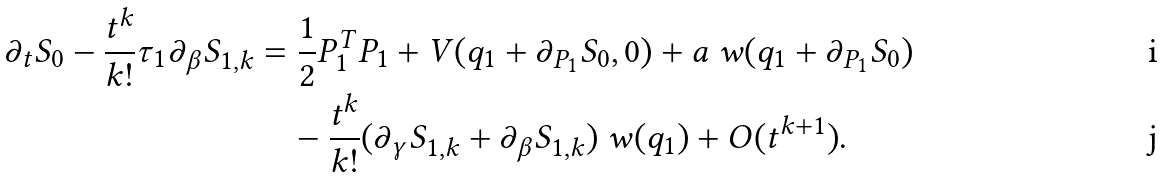Convert formula to latex. <formula><loc_0><loc_0><loc_500><loc_500>\partial _ { t } S _ { 0 } - \frac { t ^ { k } } { k ! } \tau _ { 1 } \partial _ { \beta } S _ { 1 , k } & = \frac { 1 } { 2 } P _ { 1 } ^ { T } P _ { 1 } + V ( q _ { 1 } + \partial _ { P _ { 1 } } S _ { 0 } , 0 ) + a \ w ( q _ { 1 } + \partial _ { P _ { 1 } } S _ { 0 } ) \\ & \quad - \frac { t ^ { k } } { k ! } ( \partial _ { \gamma } S _ { 1 , k } + \partial _ { \beta } S _ { 1 , k } ) \ w ( q _ { 1 } ) + O ( t ^ { k + 1 } ) .</formula> 